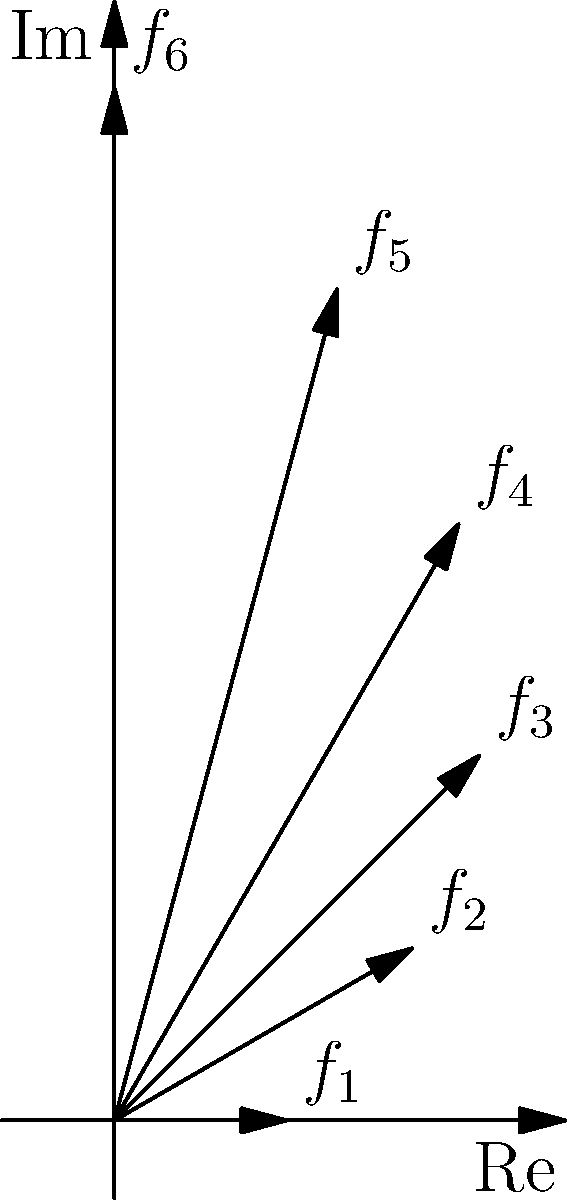In the given visualization of the harmonic series as vectors in a two-dimensional plane, which harmonic (represented by $f_n$) most closely aligns with the imaginary axis, potentially inspiring a unique tonal color in film music composition? To answer this question, we need to analyze the vectors representing the harmonics in the complex plane:

1. The vectors are labeled $f_1$ through $f_6$, representing the first six harmonics.
2. The real axis (horizontal) represents the fundamental frequency, while the imaginary axis (vertical) represents overtones.
3. The angle of each vector from the real axis increases as we move through the harmonics.
4. The vector that most closely aligns with the imaginary axis will have the largest angle from the real axis.
5. Observing the diagram, we can see that $f_6$ has the largest angle from the real axis.
6. This means that the 6th harmonic is most closely aligned with the imaginary axis.

In terms of musical composition, harmonics that align more with the imaginary axis tend to contribute more to the overtone series and can create unique timbres or tonal colors. For a film music composer, understanding and utilizing these higher harmonics can lead to more complex and interesting sound textures.
Answer: $f_6$ (6th harmonic) 